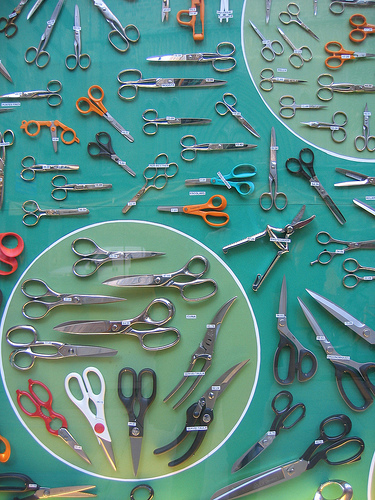Describe a day in the life of the animation world where these scissors are the main characters. In the vibrant world of animated scissor characters, each day begins with a song that harmoniously blends the sounds of cutting and snipping. The scissors wake up in their cozy toolbox home, stretching their blades and getting ready for a busy day. They embark on various adventures, from crafting beautiful paper art to helping tailors create magnificent garments. The large black scissors act as the wise leader, making sure everyone stays safe, while the red scissors cheer up everyone with their infectious enthusiasm. The playful orange scissors are often seen devising fun new games and challenges for their friends. They work together collaboratively, making every challenge seem like a delightful puzzle. As they wind down at the end of the day, they exchange stories of courage and creativity, before retreating to their toolbox, eagerly awaiting the next day's adventures. 